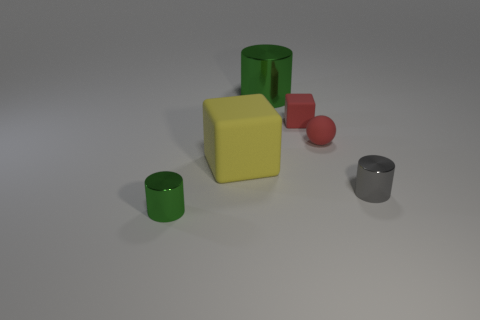Subtract all blue balls. How many green cylinders are left? 2 Subtract 1 cylinders. How many cylinders are left? 2 Add 1 big green cylinders. How many objects exist? 7 Subtract all balls. How many objects are left? 5 Add 1 big yellow objects. How many big yellow objects are left? 2 Add 4 tiny red blocks. How many tiny red blocks exist? 5 Subtract 1 red blocks. How many objects are left? 5 Subtract all rubber objects. Subtract all yellow cubes. How many objects are left? 2 